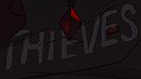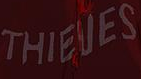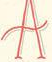What text appears in these images from left to right, separated by a semicolon? THIEVES; THIEVES; A 